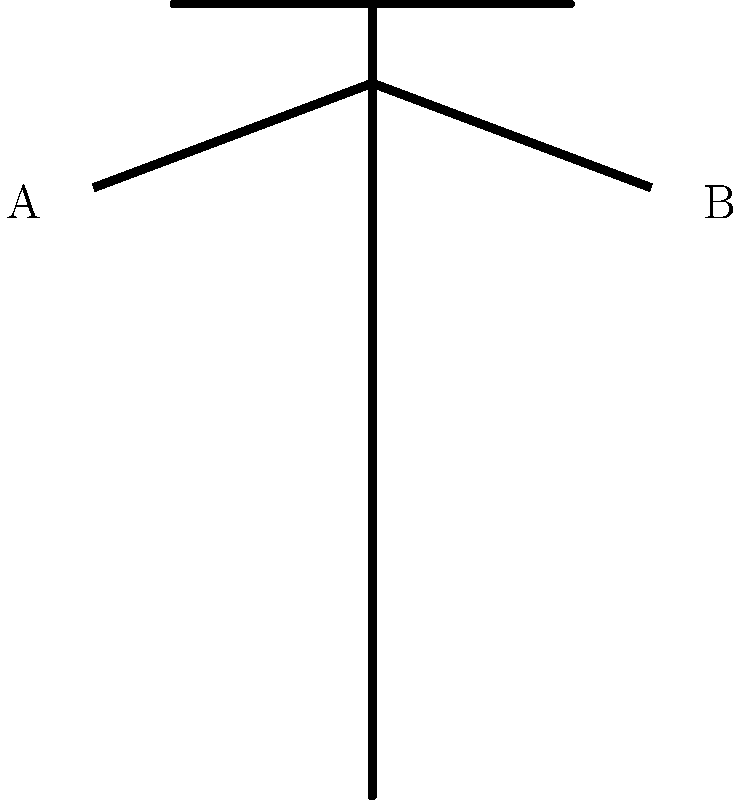In the diagram above, a police officer is shown with both arms extended horizontally. What does this hand signal typically mean in traffic control situations? To interpret this police hand signal, let's break it down step-by-step:

1. The officer's body is facing forward, indicating they are addressing traffic from multiple directions.

2. Both arms are extended horizontally to the sides, forming a T-shape with the body.

3. This position is clearly visible to drivers approaching from all directions.

4. In standard police traffic control:
   - A single arm extended usually means "stop" for the traffic facing that arm.
   - Both arms extended horizontally is a universal signal used by police officers.

5. This signal is typically used when an officer wants to stop traffic from all directions simultaneously.

6. It's often employed at intersections or in emergency situations where traffic flow needs to be halted quickly and completely.

7. The signal effectively creates a temporary "all-way stop" controlled by the officer.

Therefore, based on standard police traffic control signals, this hand position indicates that all traffic should stop.
Answer: Stop all traffic 